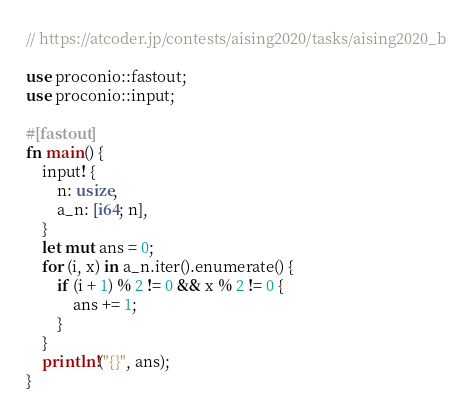<code> <loc_0><loc_0><loc_500><loc_500><_Rust_>// https://atcoder.jp/contests/aising2020/tasks/aising2020_b

use proconio::fastout;
use proconio::input;

#[fastout]
fn main() {
    input! {
        n: usize,
        a_n: [i64; n],
    }
    let mut ans = 0;
    for (i, x) in a_n.iter().enumerate() {
        if (i + 1) % 2 != 0 && x % 2 != 0 {
            ans += 1;
        }
    }
    println!("{}", ans);
}
</code> 